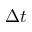Convert formula to latex. <formula><loc_0><loc_0><loc_500><loc_500>\Delta t</formula> 